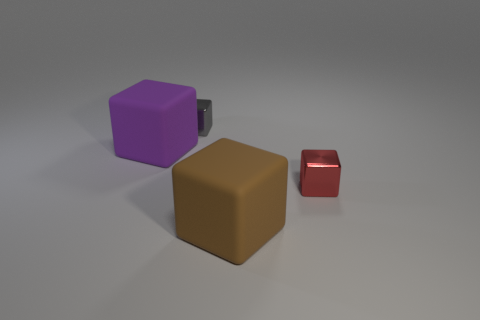There is a rubber block that is to the left of the small shiny object behind the large matte thing that is left of the tiny gray shiny object; how big is it?
Provide a succinct answer. Large. Are there any small shiny blocks that are behind the matte cube that is behind the matte thing that is in front of the purple object?
Give a very brief answer. Yes. Is the size of the rubber thing that is behind the brown matte object the same as the metallic object that is on the right side of the large brown rubber object?
Your answer should be very brief. No. Are there the same number of brown cubes right of the big brown thing and tiny red metal blocks on the left side of the red metallic object?
Give a very brief answer. Yes. Is there anything else that is the same material as the gray cube?
Ensure brevity in your answer.  Yes. Do the purple rubber block and the shiny cube that is on the right side of the gray block have the same size?
Offer a very short reply. No. There is a big cube that is in front of the tiny shiny thing right of the small gray metal block; what is it made of?
Provide a succinct answer. Rubber. Is the number of large blocks behind the brown rubber cube the same as the number of small blue rubber blocks?
Your response must be concise. No. How big is the block that is both behind the large brown object and to the right of the small gray block?
Provide a succinct answer. Small. There is a metal block that is behind the small thing right of the tiny gray cube; what color is it?
Provide a short and direct response. Gray. 